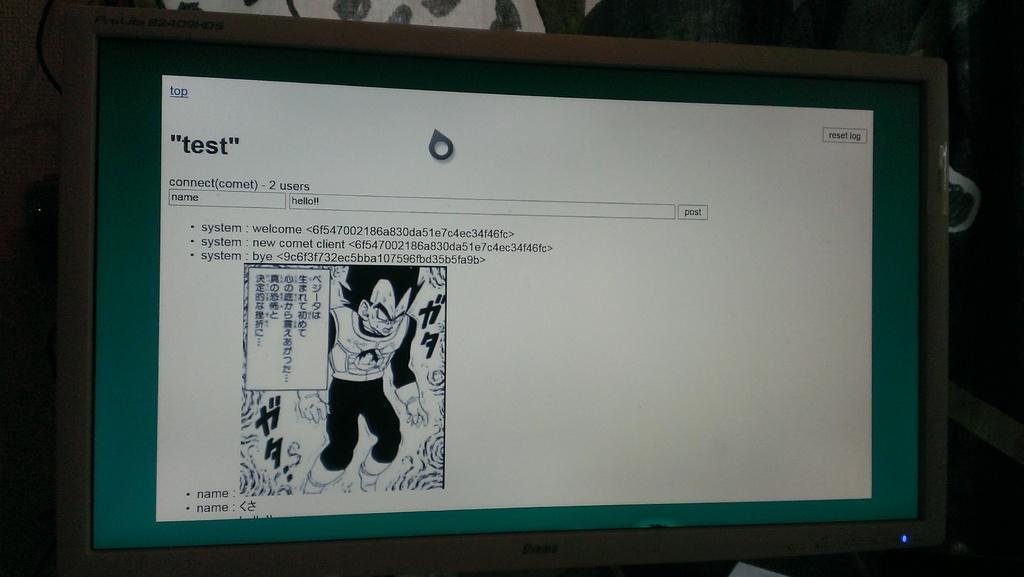<image>
Share a concise interpretation of the image provided. Computer screen with a Anime character of a mad looking monster that says test at the top of the screen. 